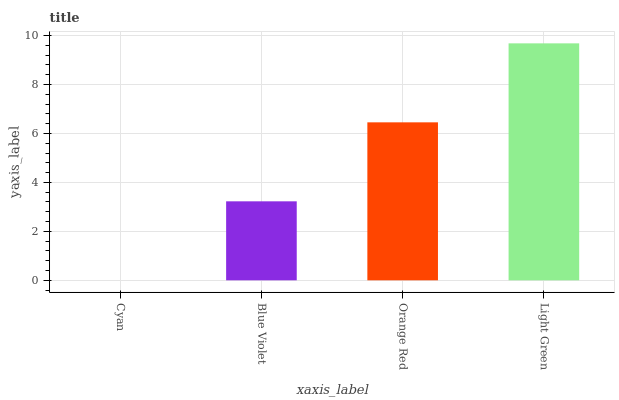Is Cyan the minimum?
Answer yes or no. Yes. Is Light Green the maximum?
Answer yes or no. Yes. Is Blue Violet the minimum?
Answer yes or no. No. Is Blue Violet the maximum?
Answer yes or no. No. Is Blue Violet greater than Cyan?
Answer yes or no. Yes. Is Cyan less than Blue Violet?
Answer yes or no. Yes. Is Cyan greater than Blue Violet?
Answer yes or no. No. Is Blue Violet less than Cyan?
Answer yes or no. No. Is Orange Red the high median?
Answer yes or no. Yes. Is Blue Violet the low median?
Answer yes or no. Yes. Is Blue Violet the high median?
Answer yes or no. No. Is Cyan the low median?
Answer yes or no. No. 